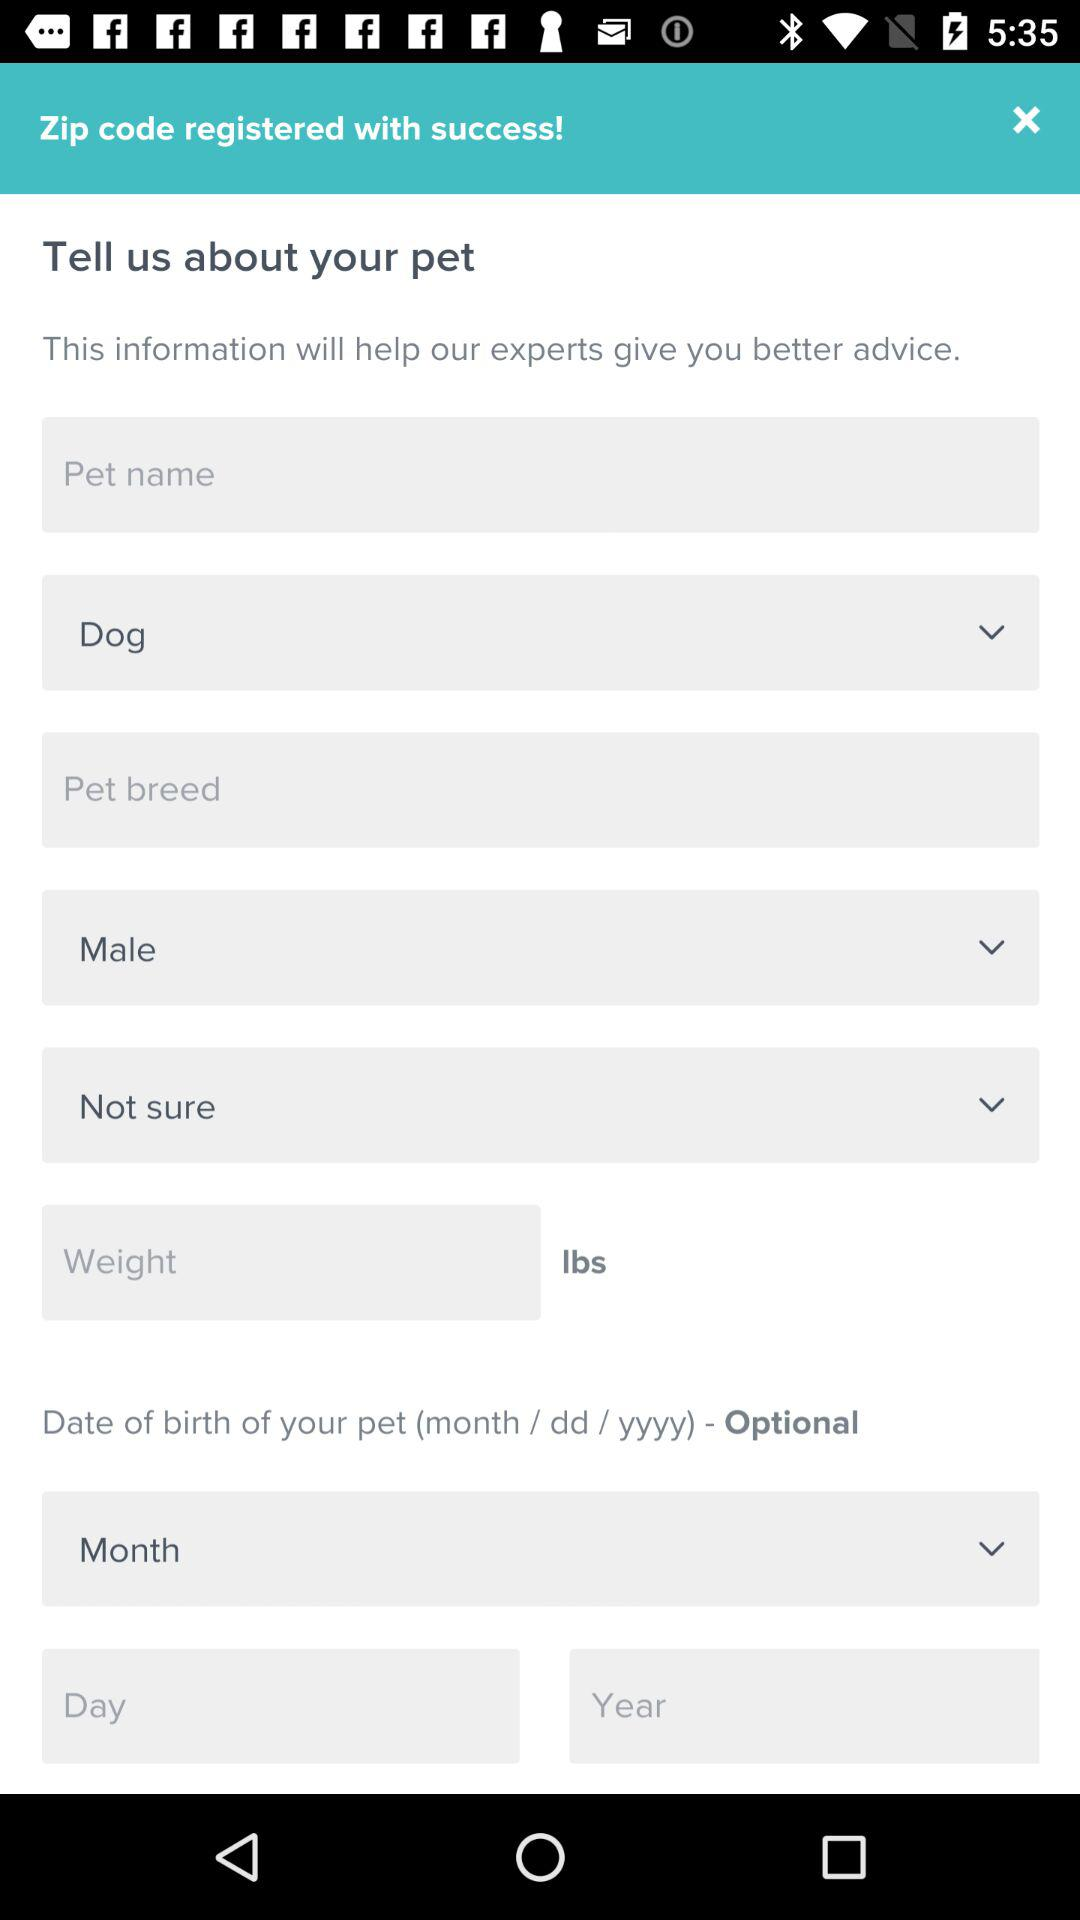Which is the selected pet? The selected pet is "Dog". 